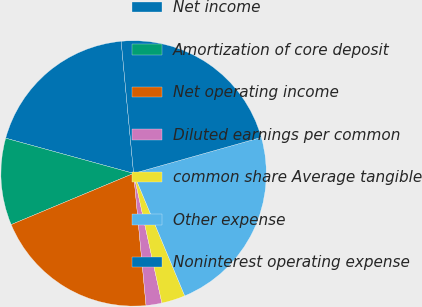Convert chart. <chart><loc_0><loc_0><loc_500><loc_500><pie_chart><fcel>Net income<fcel>Amortization of core deposit<fcel>Net operating income<fcel>Diluted earnings per common<fcel>common share Average tangible<fcel>Other expense<fcel>Noninterest operating expense<nl><fcel>19.23%<fcel>10.58%<fcel>20.19%<fcel>1.92%<fcel>2.88%<fcel>23.08%<fcel>22.12%<nl></chart> 